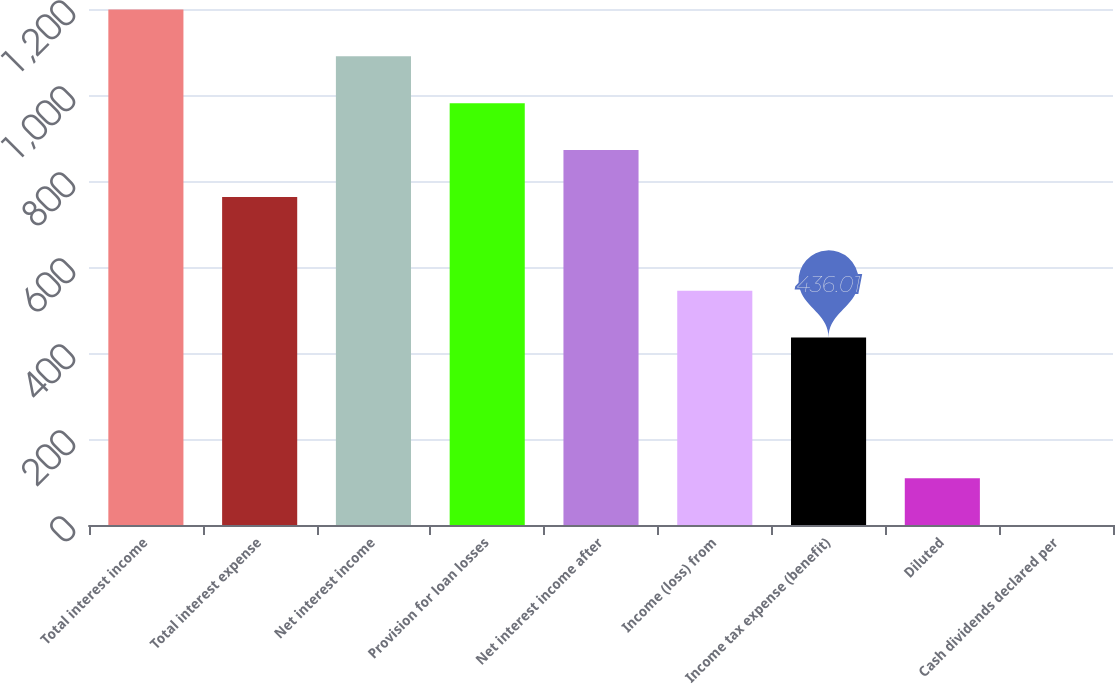Convert chart. <chart><loc_0><loc_0><loc_500><loc_500><bar_chart><fcel>Total interest income<fcel>Total interest expense<fcel>Net interest income<fcel>Provision for loan losses<fcel>Net interest income after<fcel>Income (loss) from<fcel>Income tax expense (benefit)<fcel>Diluted<fcel>Cash dividends declared per<nl><fcel>1199.01<fcel>763.01<fcel>1090.01<fcel>981.01<fcel>872.01<fcel>545.01<fcel>436.01<fcel>109.01<fcel>0.01<nl></chart> 